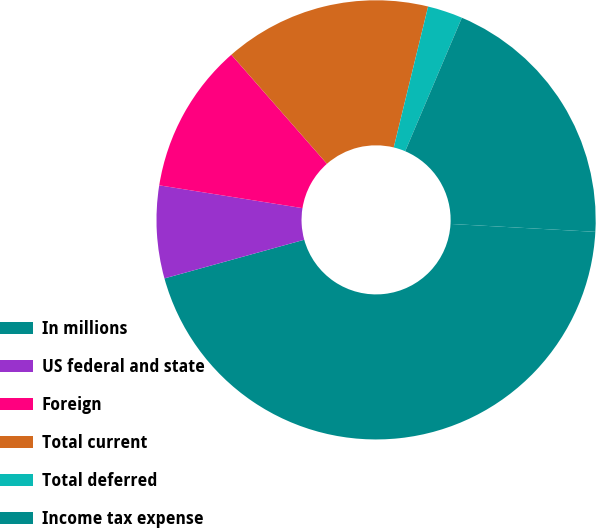Convert chart to OTSL. <chart><loc_0><loc_0><loc_500><loc_500><pie_chart><fcel>In millions<fcel>US federal and state<fcel>Foreign<fcel>Total current<fcel>Total deferred<fcel>Income tax expense<nl><fcel>44.83%<fcel>6.81%<fcel>11.03%<fcel>15.26%<fcel>2.58%<fcel>19.48%<nl></chart> 